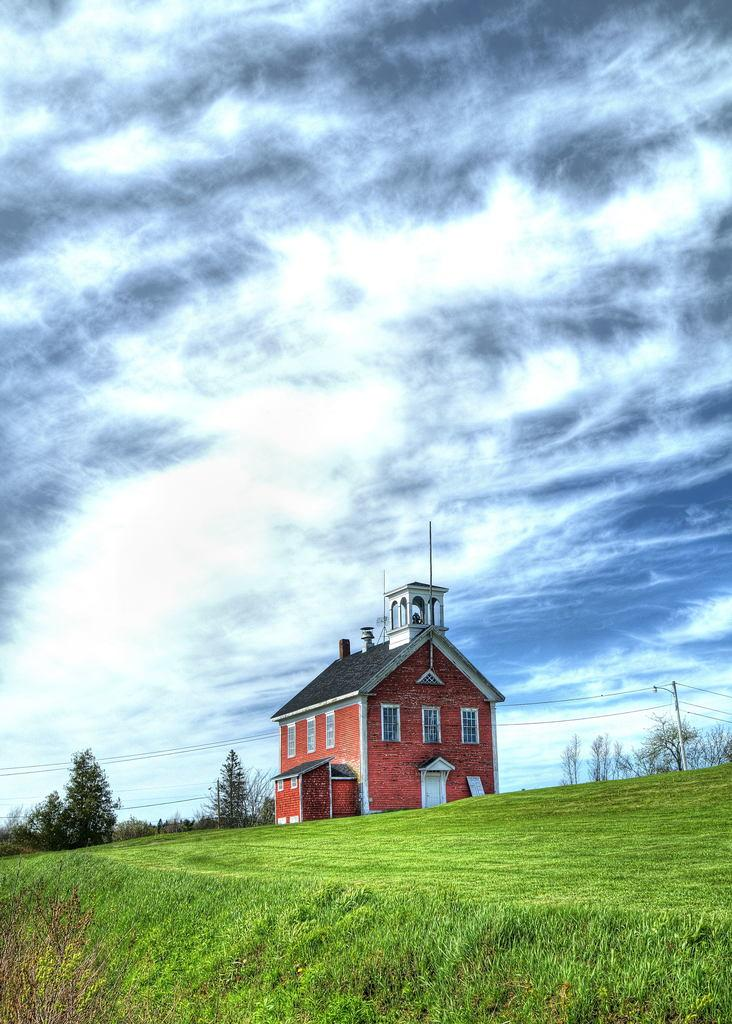What type of structure is visible in the image? There is a house in the image. What type of vegetation is present in the image? There is grass and trees in the image. What is attached to the pole in the image? There are wires attached to the pole in the image. What can be seen in the background of the image? The sky is visible in the background of the image. What is the condition of the sky in the image? There are clouds in the sky in the image. Who is the creator of the cloth seen hanging from the house in the image? There is no cloth hanging from the house in the image. 